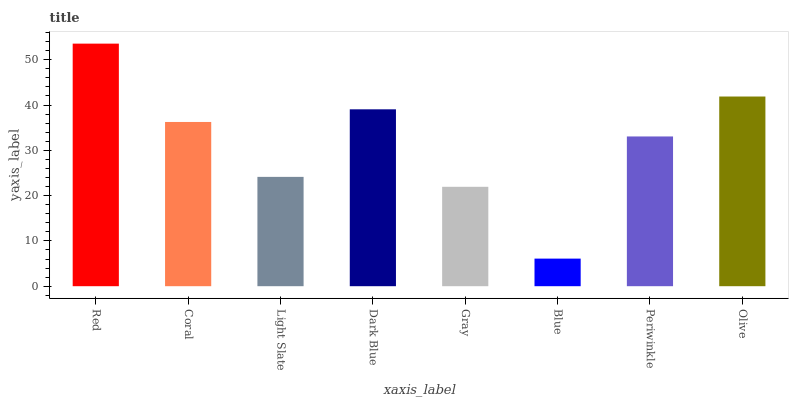Is Blue the minimum?
Answer yes or no. Yes. Is Red the maximum?
Answer yes or no. Yes. Is Coral the minimum?
Answer yes or no. No. Is Coral the maximum?
Answer yes or no. No. Is Red greater than Coral?
Answer yes or no. Yes. Is Coral less than Red?
Answer yes or no. Yes. Is Coral greater than Red?
Answer yes or no. No. Is Red less than Coral?
Answer yes or no. No. Is Coral the high median?
Answer yes or no. Yes. Is Periwinkle the low median?
Answer yes or no. Yes. Is Periwinkle the high median?
Answer yes or no. No. Is Gray the low median?
Answer yes or no. No. 